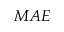Convert formula to latex. <formula><loc_0><loc_0><loc_500><loc_500>M A E</formula> 